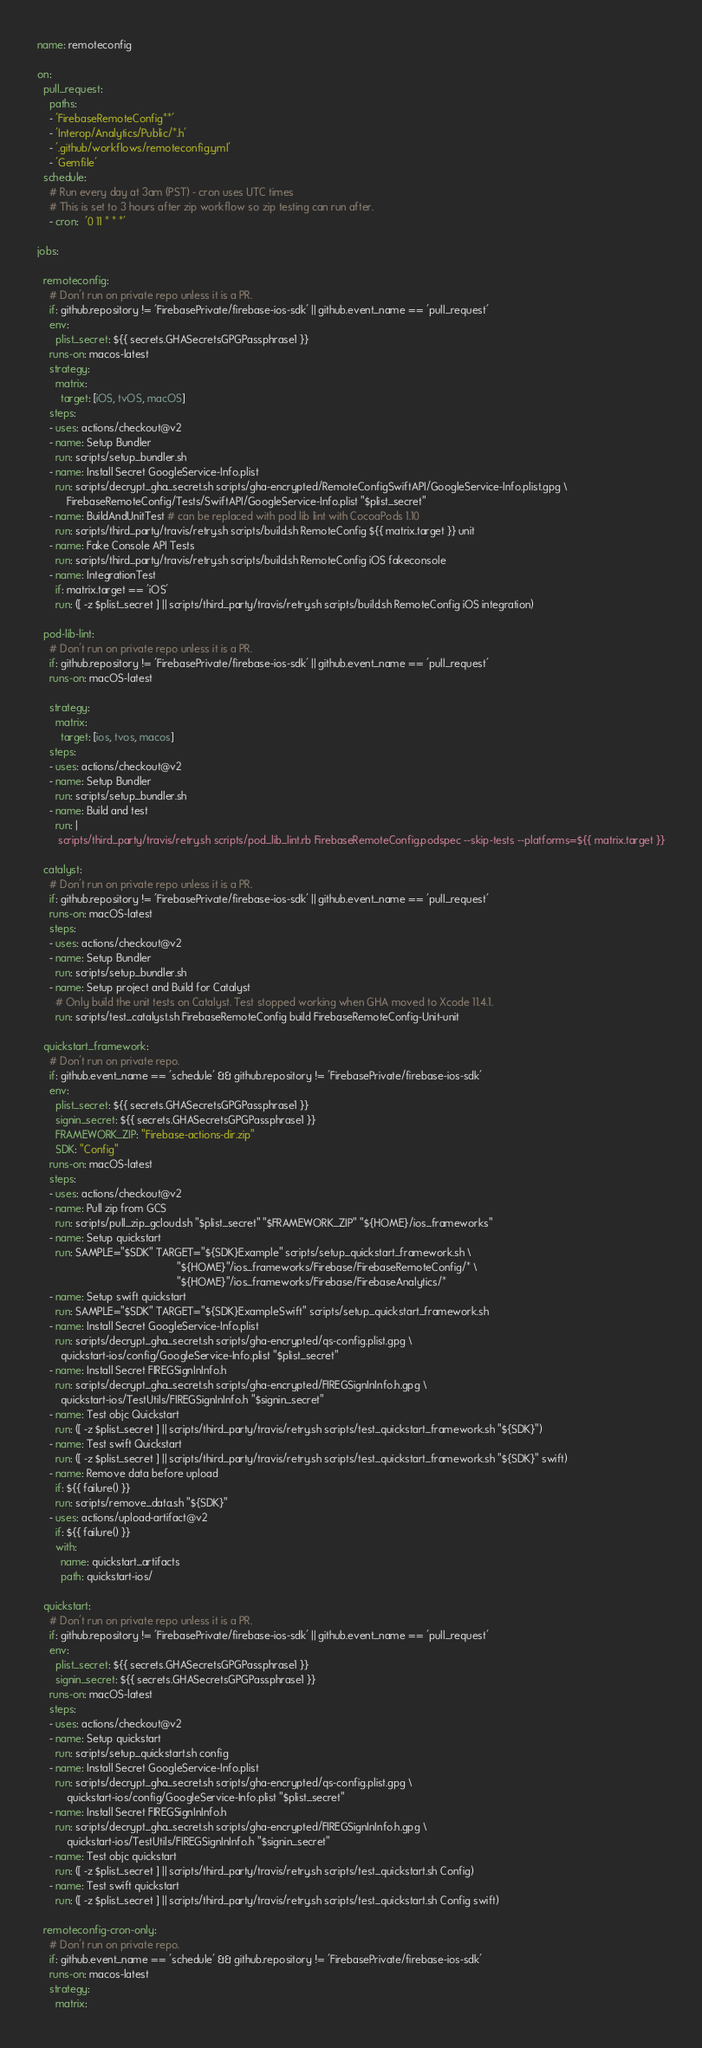Convert code to text. <code><loc_0><loc_0><loc_500><loc_500><_YAML_>name: remoteconfig

on:
  pull_request:
    paths:
    - 'FirebaseRemoteConfig**'
    - 'Interop/Analytics/Public/*.h'
    - '.github/workflows/remoteconfig.yml'
    - 'Gemfile'
  schedule:
    # Run every day at 3am (PST) - cron uses UTC times
    # This is set to 3 hours after zip workflow so zip testing can run after.
    - cron:  '0 11 * * *'

jobs:

  remoteconfig:
    # Don't run on private repo unless it is a PR.
    if: github.repository != 'FirebasePrivate/firebase-ios-sdk' || github.event_name == 'pull_request'
    env:
      plist_secret: ${{ secrets.GHASecretsGPGPassphrase1 }}
    runs-on: macos-latest
    strategy:
      matrix:
        target: [iOS, tvOS, macOS]
    steps:
    - uses: actions/checkout@v2
    - name: Setup Bundler
      run: scripts/setup_bundler.sh
    - name: Install Secret GoogleService-Info.plist
      run: scripts/decrypt_gha_secret.sh scripts/gha-encrypted/RemoteConfigSwiftAPI/GoogleService-Info.plist.gpg \
          FirebaseRemoteConfig/Tests/SwiftAPI/GoogleService-Info.plist "$plist_secret"
    - name: BuildAndUnitTest # can be replaced with pod lib lint with CocoaPods 1.10
      run: scripts/third_party/travis/retry.sh scripts/build.sh RemoteConfig ${{ matrix.target }} unit
    - name: Fake Console API Tests
      run: scripts/third_party/travis/retry.sh scripts/build.sh RemoteConfig iOS fakeconsole
    - name: IntegrationTest
      if: matrix.target == 'iOS'
      run: ([ -z $plist_secret ] || scripts/third_party/travis/retry.sh scripts/build.sh RemoteConfig iOS integration)

  pod-lib-lint:
    # Don't run on private repo unless it is a PR.
    if: github.repository != 'FirebasePrivate/firebase-ios-sdk' || github.event_name == 'pull_request'
    runs-on: macOS-latest

    strategy:
      matrix:
        target: [ios, tvos, macos]
    steps:
    - uses: actions/checkout@v2
    - name: Setup Bundler
      run: scripts/setup_bundler.sh
    - name: Build and test
      run: |
       scripts/third_party/travis/retry.sh scripts/pod_lib_lint.rb FirebaseRemoteConfig.podspec --skip-tests --platforms=${{ matrix.target }}

  catalyst:
    # Don't run on private repo unless it is a PR.
    if: github.repository != 'FirebasePrivate/firebase-ios-sdk' || github.event_name == 'pull_request'
    runs-on: macOS-latest
    steps:
    - uses: actions/checkout@v2
    - name: Setup Bundler
      run: scripts/setup_bundler.sh
    - name: Setup project and Build for Catalyst
      # Only build the unit tests on Catalyst. Test stopped working when GHA moved to Xcode 11.4.1.
      run: scripts/test_catalyst.sh FirebaseRemoteConfig build FirebaseRemoteConfig-Unit-unit

  quickstart_framework:
    # Don't run on private repo.
    if: github.event_name == 'schedule' && github.repository != 'FirebasePrivate/firebase-ios-sdk'
    env:
      plist_secret: ${{ secrets.GHASecretsGPGPassphrase1 }}
      signin_secret: ${{ secrets.GHASecretsGPGPassphrase1 }}
      FRAMEWORK_ZIP: "Firebase-actions-dir.zip"
      SDK: "Config"
    runs-on: macOS-latest
    steps:
    - uses: actions/checkout@v2
    - name: Pull zip from GCS
      run: scripts/pull_zip_gcloud.sh "$plist_secret" "$FRAMEWORK_ZIP" "${HOME}/ios_frameworks"
    - name: Setup quickstart
      run: SAMPLE="$SDK" TARGET="${SDK}Example" scripts/setup_quickstart_framework.sh \
                                               "${HOME}"/ios_frameworks/Firebase/FirebaseRemoteConfig/* \
                                               "${HOME}"/ios_frameworks/Firebase/FirebaseAnalytics/*
    - name: Setup swift quickstart
      run: SAMPLE="$SDK" TARGET="${SDK}ExampleSwift" scripts/setup_quickstart_framework.sh
    - name: Install Secret GoogleService-Info.plist
      run: scripts/decrypt_gha_secret.sh scripts/gha-encrypted/qs-config.plist.gpg \
        quickstart-ios/config/GoogleService-Info.plist "$plist_secret"
    - name: Install Secret FIREGSignInInfo.h
      run: scripts/decrypt_gha_secret.sh scripts/gha-encrypted/FIREGSignInInfo.h.gpg \
        quickstart-ios/TestUtils/FIREGSignInInfo.h "$signin_secret"
    - name: Test objc Quickstart
      run: ([ -z $plist_secret ] || scripts/third_party/travis/retry.sh scripts/test_quickstart_framework.sh "${SDK}")
    - name: Test swift Quickstart
      run: ([ -z $plist_secret ] || scripts/third_party/travis/retry.sh scripts/test_quickstart_framework.sh "${SDK}" swift)
    - name: Remove data before upload
      if: ${{ failure() }}
      run: scripts/remove_data.sh "${SDK}"
    - uses: actions/upload-artifact@v2
      if: ${{ failure() }}
      with:
        name: quickstart_artifacts
        path: quickstart-ios/

  quickstart:
    # Don't run on private repo unless it is a PR.
    if: github.repository != 'FirebasePrivate/firebase-ios-sdk' || github.event_name == 'pull_request'
    env:
      plist_secret: ${{ secrets.GHASecretsGPGPassphrase1 }}
      signin_secret: ${{ secrets.GHASecretsGPGPassphrase1 }}
    runs-on: macOS-latest
    steps:
    - uses: actions/checkout@v2
    - name: Setup quickstart
      run: scripts/setup_quickstart.sh config
    - name: Install Secret GoogleService-Info.plist
      run: scripts/decrypt_gha_secret.sh scripts/gha-encrypted/qs-config.plist.gpg \
          quickstart-ios/config/GoogleService-Info.plist "$plist_secret"
    - name: Install Secret FIREGSignInInfo.h
      run: scripts/decrypt_gha_secret.sh scripts/gha-encrypted/FIREGSignInInfo.h.gpg \
          quickstart-ios/TestUtils/FIREGSignInInfo.h "$signin_secret"
    - name: Test objc quickstart
      run: ([ -z $plist_secret ] || scripts/third_party/travis/retry.sh scripts/test_quickstart.sh Config)
    - name: Test swift quickstart
      run: ([ -z $plist_secret ] || scripts/third_party/travis/retry.sh scripts/test_quickstart.sh Config swift)

  remoteconfig-cron-only:
    # Don't run on private repo.
    if: github.event_name == 'schedule' && github.repository != 'FirebasePrivate/firebase-ios-sdk'
    runs-on: macos-latest
    strategy:
      matrix:</code> 